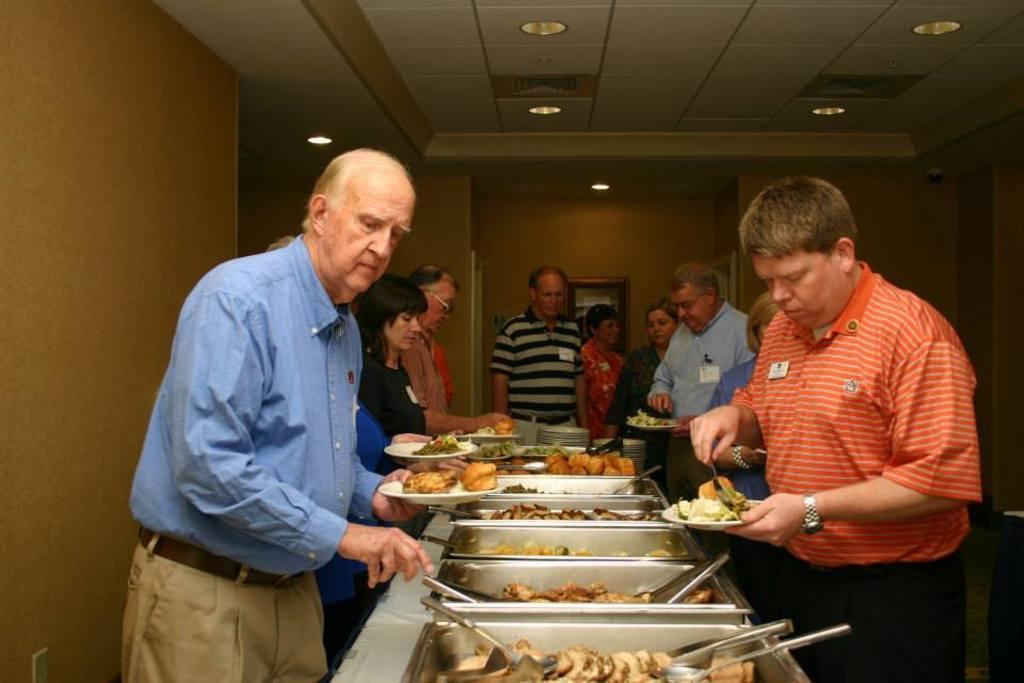Could you give a brief overview of what you see in this image? In this image I can see some people. I can see some food items in the plate. At the top I can see the lights. 